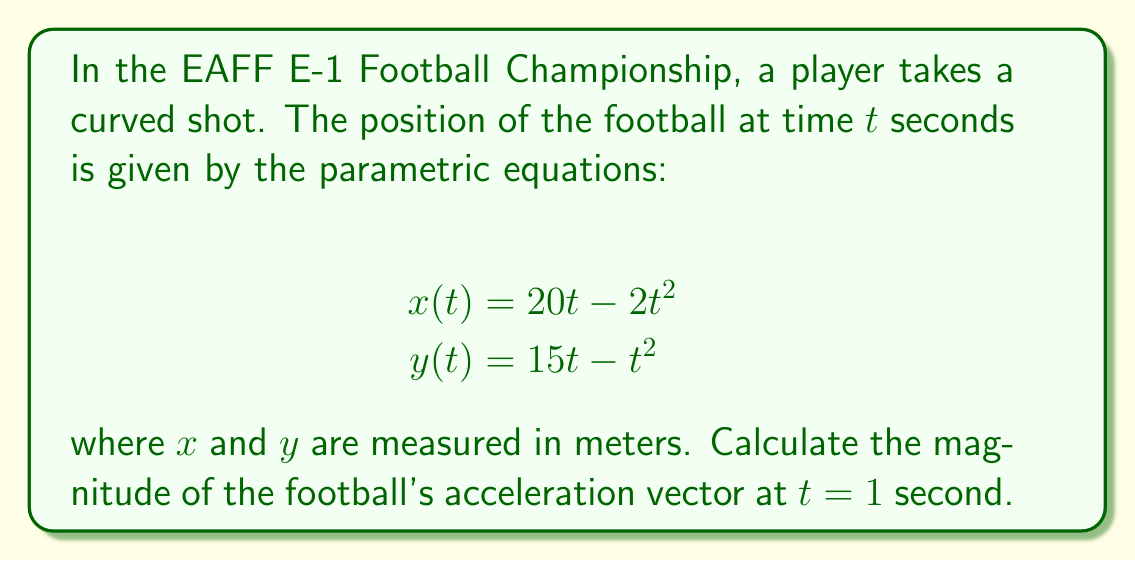Could you help me with this problem? To find the magnitude of the acceleration vector, we need to follow these steps:

1) First, we need to find the velocity components by differentiating the position equations:

   $$v_x(t) = \frac{dx}{dt} = 20 - 4t$$
   $$v_y(t) = \frac{dy}{dt} = 15 - 2t$$

2) Now, we find the acceleration components by differentiating the velocity equations:

   $$a_x(t) = \frac{dv_x}{dt} = -4$$
   $$a_y(t) = \frac{dv_y}{dt} = -2$$

3) The acceleration vector at any time $t$ is $\vec{a}(t) = (a_x(t), a_y(t)) = (-4, -2)$

4) The magnitude of the acceleration vector is given by:

   $$|\vec{a}| = \sqrt{(a_x)^2 + (a_y)^2}$$

5) Substituting the values:

   $$|\vec{a}| = \sqrt{(-4)^2 + (-2)^2}$$

6) Simplifying:

   $$|\vec{a}| = \sqrt{16 + 4} = \sqrt{20} = 2\sqrt{5}$$

Therefore, the magnitude of the acceleration vector at $t = 1$ second (and at all times) is $2\sqrt{5}$ m/s².
Answer: $2\sqrt{5}$ m/s² 